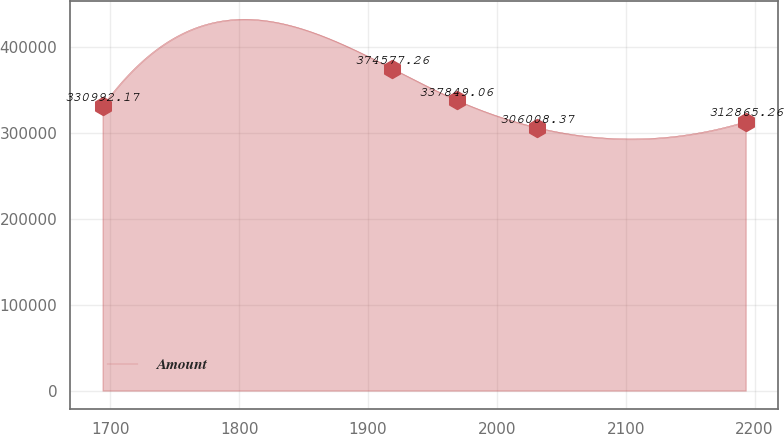Convert chart. <chart><loc_0><loc_0><loc_500><loc_500><line_chart><ecel><fcel>Amount<nl><fcel>1694.05<fcel>330992<nl><fcel>1918.86<fcel>374577<nl><fcel>1968.77<fcel>337849<nl><fcel>2030.97<fcel>306008<nl><fcel>2193.13<fcel>312865<nl></chart> 